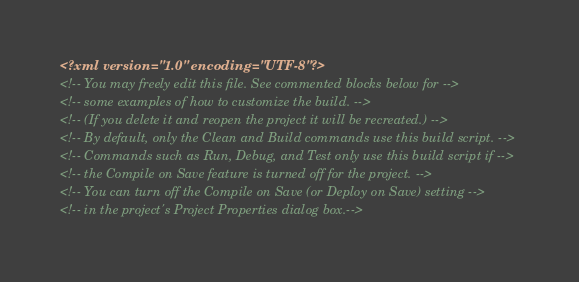Convert code to text. <code><loc_0><loc_0><loc_500><loc_500><_XML_><?xml version="1.0" encoding="UTF-8"?>
<!-- You may freely edit this file. See commented blocks below for -->
<!-- some examples of how to customize the build. -->
<!-- (If you delete it and reopen the project it will be recreated.) -->
<!-- By default, only the Clean and Build commands use this build script. -->
<!-- Commands such as Run, Debug, and Test only use this build script if -->
<!-- the Compile on Save feature is turned off for the project. -->
<!-- You can turn off the Compile on Save (or Deploy on Save) setting -->
<!-- in the project's Project Properties dialog box.--></code> 